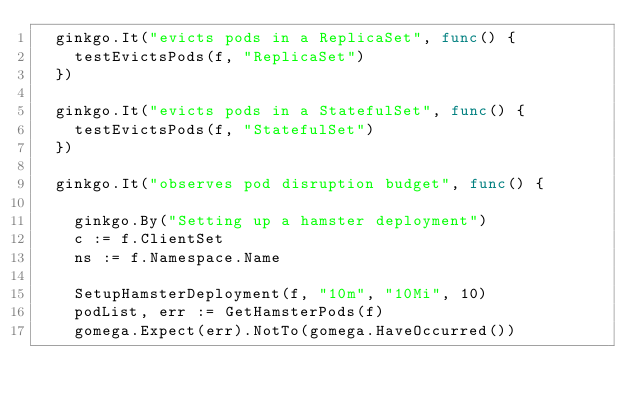Convert code to text. <code><loc_0><loc_0><loc_500><loc_500><_Go_>	ginkgo.It("evicts pods in a ReplicaSet", func() {
		testEvictsPods(f, "ReplicaSet")
	})

	ginkgo.It("evicts pods in a StatefulSet", func() {
		testEvictsPods(f, "StatefulSet")
	})

	ginkgo.It("observes pod disruption budget", func() {

		ginkgo.By("Setting up a hamster deployment")
		c := f.ClientSet
		ns := f.Namespace.Name

		SetupHamsterDeployment(f, "10m", "10Mi", 10)
		podList, err := GetHamsterPods(f)
		gomega.Expect(err).NotTo(gomega.HaveOccurred())</code> 